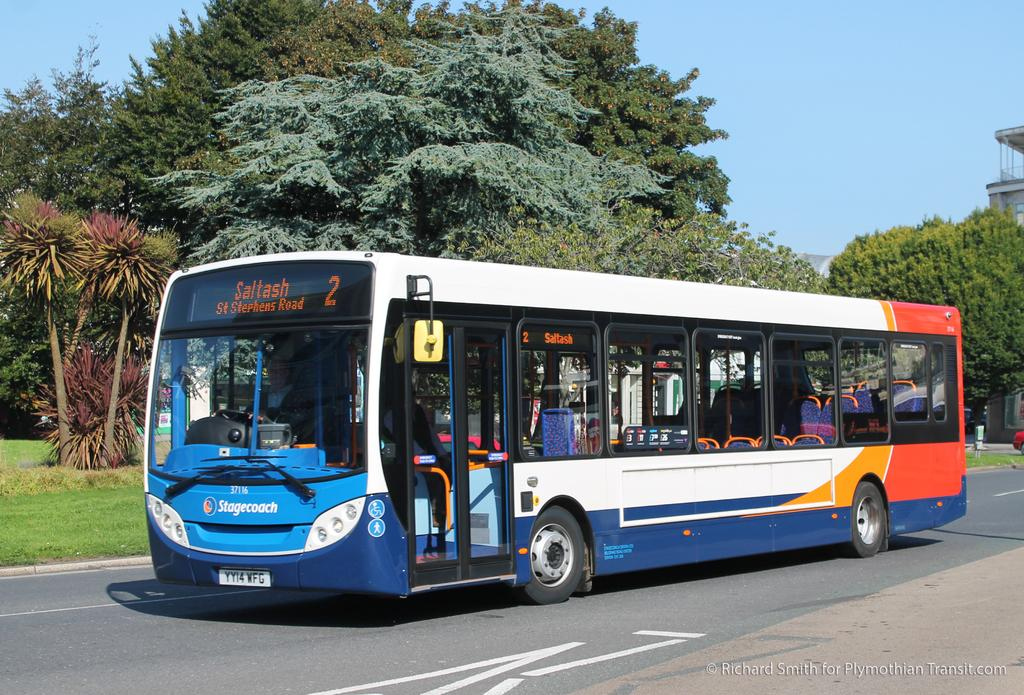<image>
Offer a succinct explanation of the picture presented. The display on the front of a bus indicates its destination is St Stephens Road. 